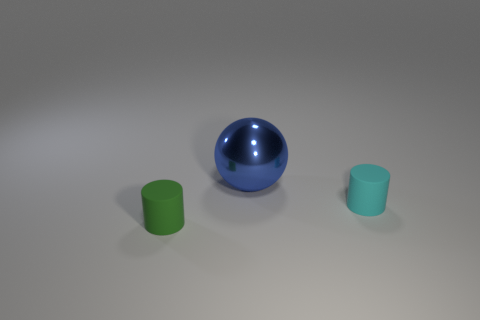Are there an equal number of large blue metallic balls that are behind the large blue shiny object and yellow metal objects?
Make the answer very short. Yes. There is a tiny cylinder right of the blue thing that is to the left of the small cyan matte cylinder behind the green matte thing; what is it made of?
Offer a terse response. Rubber. What color is the small cylinder right of the blue sphere?
Your response must be concise. Cyan. Are there any other things that are the same shape as the small green matte object?
Your answer should be compact. Yes. There is a matte object on the left side of the rubber thing on the right side of the big blue object; how big is it?
Keep it short and to the point. Small. Are there an equal number of big blue spheres that are behind the ball and small green matte things that are on the right side of the tiny green matte cylinder?
Offer a terse response. Yes. Is there anything else that has the same size as the blue thing?
Provide a succinct answer. No. The thing that is the same material as the cyan cylinder is what color?
Your response must be concise. Green. Are the big blue sphere and the small thing that is on the right side of the large shiny thing made of the same material?
Ensure brevity in your answer.  No. What is the color of the object that is both in front of the blue sphere and behind the tiny green object?
Ensure brevity in your answer.  Cyan. 